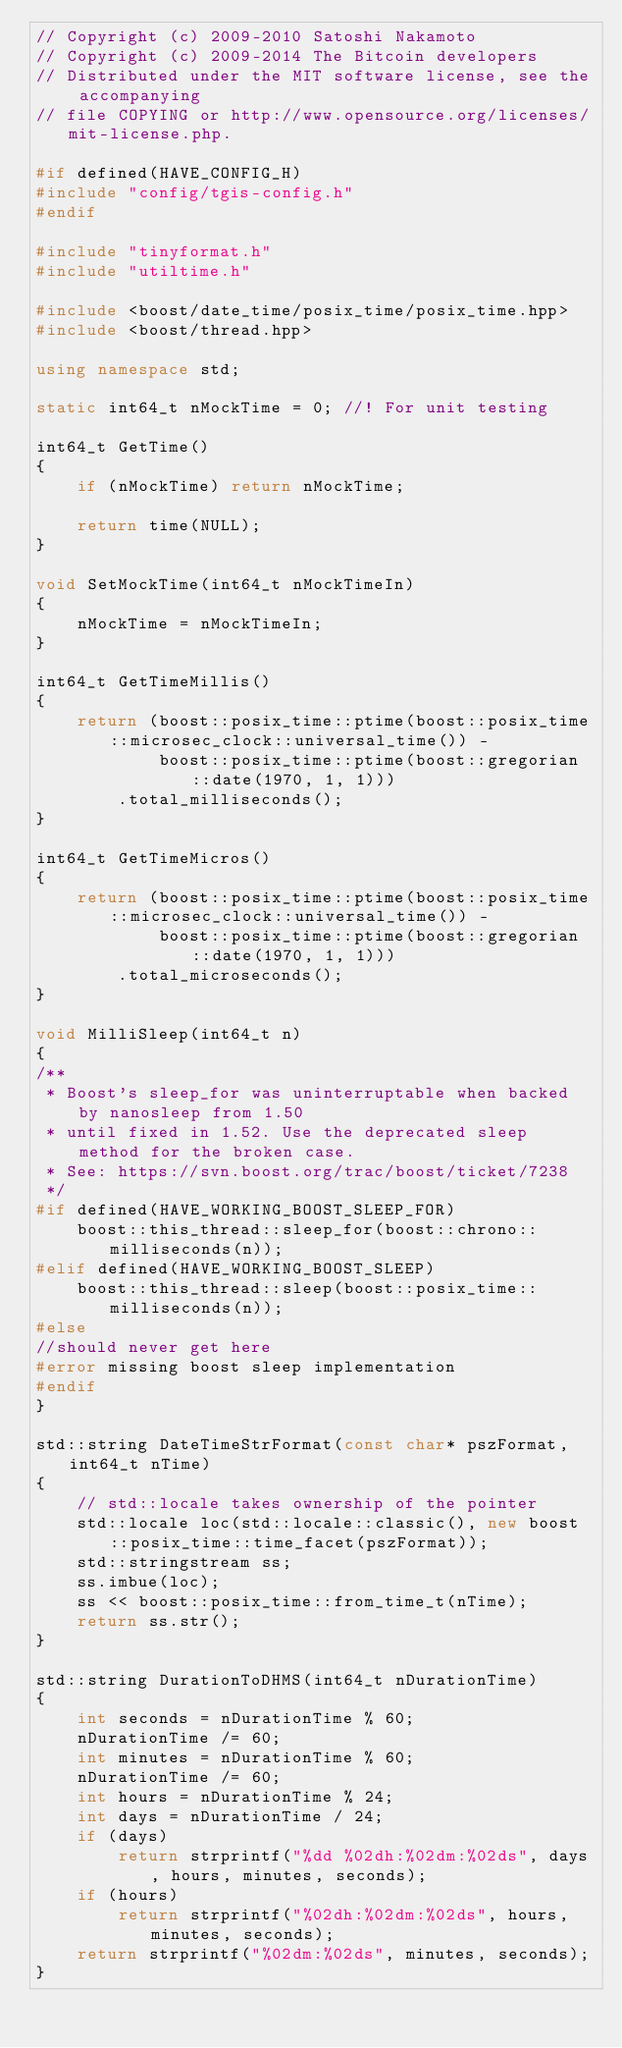Convert code to text. <code><loc_0><loc_0><loc_500><loc_500><_C++_>// Copyright (c) 2009-2010 Satoshi Nakamoto
// Copyright (c) 2009-2014 The Bitcoin developers
// Distributed under the MIT software license, see the accompanying
// file COPYING or http://www.opensource.org/licenses/mit-license.php.

#if defined(HAVE_CONFIG_H)
#include "config/tgis-config.h"
#endif

#include "tinyformat.h"
#include "utiltime.h"

#include <boost/date_time/posix_time/posix_time.hpp>
#include <boost/thread.hpp>

using namespace std;

static int64_t nMockTime = 0; //! For unit testing

int64_t GetTime()
{
    if (nMockTime) return nMockTime;

    return time(NULL);
}

void SetMockTime(int64_t nMockTimeIn)
{
    nMockTime = nMockTimeIn;
}

int64_t GetTimeMillis()
{
    return (boost::posix_time::ptime(boost::posix_time::microsec_clock::universal_time()) -
            boost::posix_time::ptime(boost::gregorian::date(1970, 1, 1)))
        .total_milliseconds();
}

int64_t GetTimeMicros()
{
    return (boost::posix_time::ptime(boost::posix_time::microsec_clock::universal_time()) -
            boost::posix_time::ptime(boost::gregorian::date(1970, 1, 1)))
        .total_microseconds();
}

void MilliSleep(int64_t n)
{
/**
 * Boost's sleep_for was uninterruptable when backed by nanosleep from 1.50
 * until fixed in 1.52. Use the deprecated sleep method for the broken case.
 * See: https://svn.boost.org/trac/boost/ticket/7238
 */
#if defined(HAVE_WORKING_BOOST_SLEEP_FOR)
    boost::this_thread::sleep_for(boost::chrono::milliseconds(n));
#elif defined(HAVE_WORKING_BOOST_SLEEP)
    boost::this_thread::sleep(boost::posix_time::milliseconds(n));
#else
//should never get here
#error missing boost sleep implementation
#endif
}

std::string DateTimeStrFormat(const char* pszFormat, int64_t nTime)
{
    // std::locale takes ownership of the pointer
    std::locale loc(std::locale::classic(), new boost::posix_time::time_facet(pszFormat));
    std::stringstream ss;
    ss.imbue(loc);
    ss << boost::posix_time::from_time_t(nTime);
    return ss.str();
}

std::string DurationToDHMS(int64_t nDurationTime)
{
    int seconds = nDurationTime % 60;
    nDurationTime /= 60;
    int minutes = nDurationTime % 60;
    nDurationTime /= 60;
    int hours = nDurationTime % 24;
    int days = nDurationTime / 24;
    if (days)
        return strprintf("%dd %02dh:%02dm:%02ds", days, hours, minutes, seconds);
    if (hours)
        return strprintf("%02dh:%02dm:%02ds", hours, minutes, seconds);
    return strprintf("%02dm:%02ds", minutes, seconds);
}
</code> 